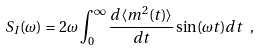Convert formula to latex. <formula><loc_0><loc_0><loc_500><loc_500>S _ { I } ( \omega ) = 2 \omega \int _ { 0 } ^ { \infty } \frac { d \langle m ^ { 2 } ( t ) \rangle } { d t } \sin ( \omega t ) d t \ ,</formula> 